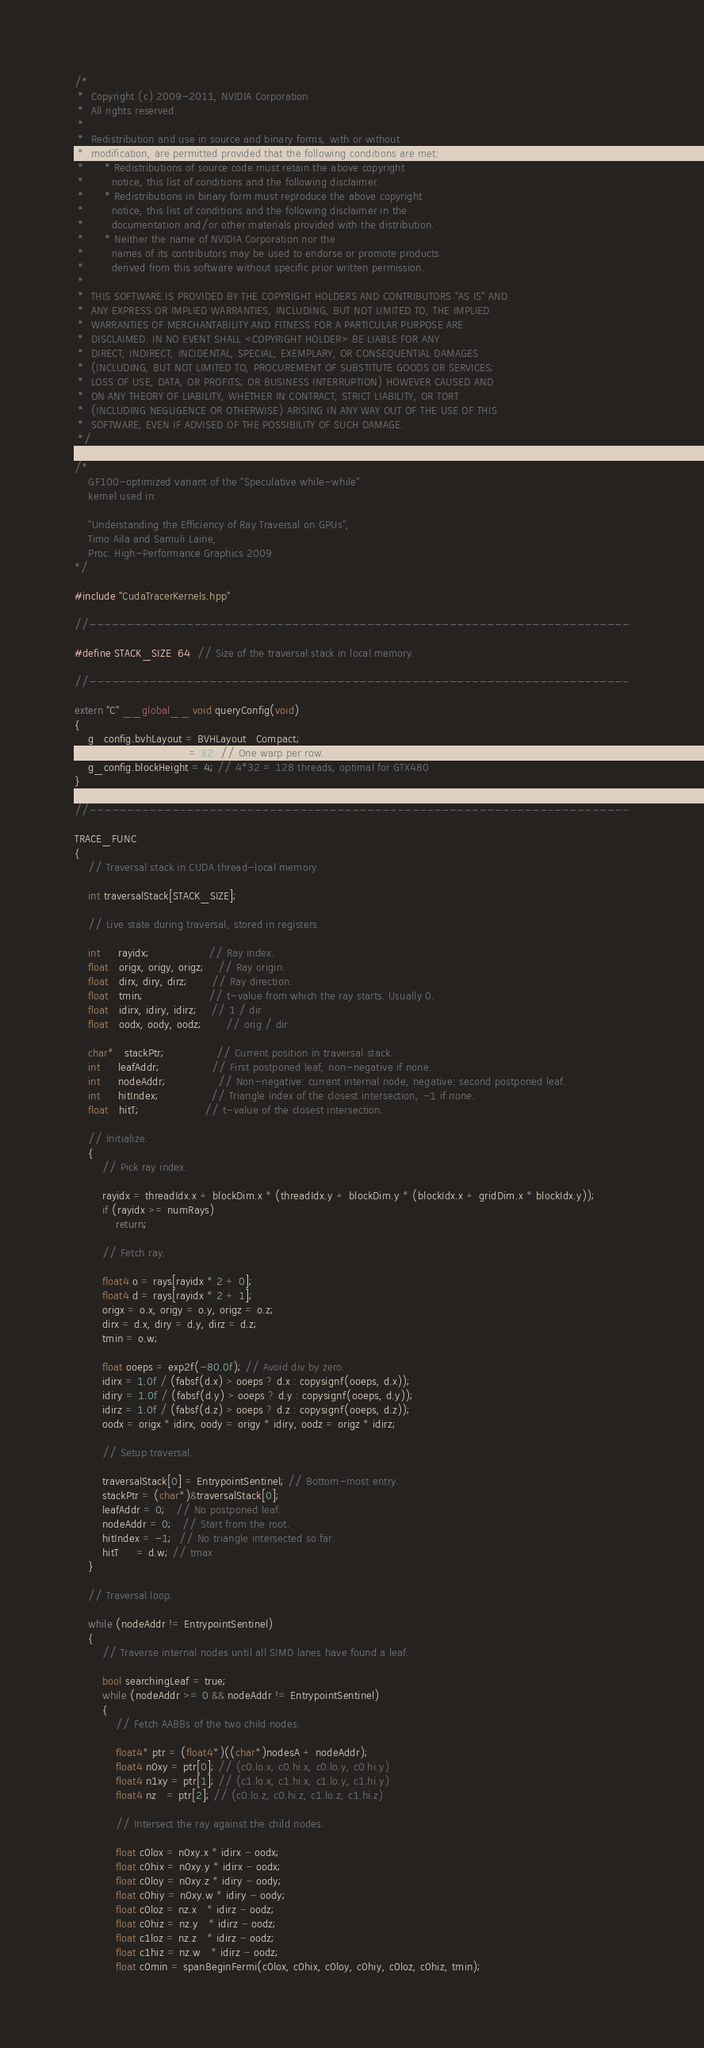Convert code to text. <code><loc_0><loc_0><loc_500><loc_500><_Cuda_>/*
 *  Copyright (c) 2009-2011, NVIDIA Corporation
 *  All rights reserved.
 *
 *  Redistribution and use in source and binary forms, with or without
 *  modification, are permitted provided that the following conditions are met:
 *      * Redistributions of source code must retain the above copyright
 *        notice, this list of conditions and the following disclaimer.
 *      * Redistributions in binary form must reproduce the above copyright
 *        notice, this list of conditions and the following disclaimer in the
 *        documentation and/or other materials provided with the distribution.
 *      * Neither the name of NVIDIA Corporation nor the
 *        names of its contributors may be used to endorse or promote products
 *        derived from this software without specific prior written permission.
 *
 *  THIS SOFTWARE IS PROVIDED BY THE COPYRIGHT HOLDERS AND CONTRIBUTORS "AS IS" AND
 *  ANY EXPRESS OR IMPLIED WARRANTIES, INCLUDING, BUT NOT LIMITED TO, THE IMPLIED
 *  WARRANTIES OF MERCHANTABILITY AND FITNESS FOR A PARTICULAR PURPOSE ARE
 *  DISCLAIMED. IN NO EVENT SHALL <COPYRIGHT HOLDER> BE LIABLE FOR ANY
 *  DIRECT, INDIRECT, INCIDENTAL, SPECIAL, EXEMPLARY, OR CONSEQUENTIAL DAMAGES
 *  (INCLUDING, BUT NOT LIMITED TO, PROCUREMENT OF SUBSTITUTE GOODS OR SERVICES;
 *  LOSS OF USE, DATA, OR PROFITS; OR BUSINESS INTERRUPTION) HOWEVER CAUSED AND
 *  ON ANY THEORY OF LIABILITY, WHETHER IN CONTRACT, STRICT LIABILITY, OR TORT
 *  (INCLUDING NEGLIGENCE OR OTHERWISE) ARISING IN ANY WAY OUT OF THE USE OF THIS
 *  SOFTWARE, EVEN IF ADVISED OF THE POSSIBILITY OF SUCH DAMAGE.
 */

/*
    GF100-optimized variant of the "Speculative while-while"
    kernel used in:

    "Understanding the Efficiency of Ray Traversal on GPUs",
    Timo Aila and Samuli Laine,
    Proc. High-Performance Graphics 2009
*/

#include "CudaTracerKernels.hpp"

//------------------------------------------------------------------------

#define STACK_SIZE  64  // Size of the traversal stack in local memory.

//------------------------------------------------------------------------

extern "C" __global__ void queryConfig(void)
{
    g_config.bvhLayout = BVHLayout_Compact;
    g_config.blockWidth = 32; // One warp per row.
    g_config.blockHeight = 4; // 4*32 = 128 threads, optimal for GTX480
}

//------------------------------------------------------------------------

TRACE_FUNC
{
    // Traversal stack in CUDA thread-local memory.

    int traversalStack[STACK_SIZE];

    // Live state during traversal, stored in registers.

    int     rayidx;                 // Ray index.
    float   origx, origy, origz;    // Ray origin.
    float   dirx, diry, dirz;       // Ray direction.
    float   tmin;                   // t-value from which the ray starts. Usually 0.
    float   idirx, idiry, idirz;    // 1 / dir
    float   oodx, oody, oodz;       // orig / dir

    char*   stackPtr;               // Current position in traversal stack.
    int     leafAddr;               // First postponed leaf, non-negative if none.
    int     nodeAddr;               // Non-negative: current internal node, negative: second postponed leaf.
    int     hitIndex;               // Triangle index of the closest intersection, -1 if none.
    float   hitT;                   // t-value of the closest intersection.

    // Initialize.
    {
        // Pick ray index.

        rayidx = threadIdx.x + blockDim.x * (threadIdx.y + blockDim.y * (blockIdx.x + gridDim.x * blockIdx.y));
        if (rayidx >= numRays)
            return;

        // Fetch ray.

        float4 o = rays[rayidx * 2 + 0];
        float4 d = rays[rayidx * 2 + 1];
        origx = o.x, origy = o.y, origz = o.z;
        dirx = d.x, diry = d.y, dirz = d.z;
        tmin = o.w;

        float ooeps = exp2f(-80.0f); // Avoid div by zero.
        idirx = 1.0f / (fabsf(d.x) > ooeps ? d.x : copysignf(ooeps, d.x));
        idiry = 1.0f / (fabsf(d.y) > ooeps ? d.y : copysignf(ooeps, d.y));
        idirz = 1.0f / (fabsf(d.z) > ooeps ? d.z : copysignf(ooeps, d.z));
        oodx = origx * idirx, oody = origy * idiry, oodz = origz * idirz;

        // Setup traversal.

        traversalStack[0] = EntrypointSentinel; // Bottom-most entry.
        stackPtr = (char*)&traversalStack[0];
        leafAddr = 0;   // No postponed leaf.
        nodeAddr = 0;   // Start from the root.
        hitIndex = -1;  // No triangle intersected so far.
        hitT     = d.w; // tmax
    }

    // Traversal loop.

    while (nodeAddr != EntrypointSentinel)
    {
        // Traverse internal nodes until all SIMD lanes have found a leaf.

        bool searchingLeaf = true;
        while (nodeAddr >= 0 && nodeAddr != EntrypointSentinel)
        {
            // Fetch AABBs of the two child nodes.

            float4* ptr = (float4*)((char*)nodesA + nodeAddr);
            float4 n0xy = ptr[0]; // (c0.lo.x, c0.hi.x, c0.lo.y, c0.hi.y)
            float4 n1xy = ptr[1]; // (c1.lo.x, c1.hi.x, c1.lo.y, c1.hi.y)
            float4 nz   = ptr[2]; // (c0.lo.z, c0.hi.z, c1.lo.z, c1.hi.z)

            // Intersect the ray against the child nodes.

            float c0lox = n0xy.x * idirx - oodx;
            float c0hix = n0xy.y * idirx - oodx;
            float c0loy = n0xy.z * idiry - oody;
            float c0hiy = n0xy.w * idiry - oody;
            float c0loz = nz.x   * idirz - oodz;
            float c0hiz = nz.y   * idirz - oodz;
            float c1loz = nz.z   * idirz - oodz;
            float c1hiz = nz.w   * idirz - oodz;
			float c0min = spanBeginFermi(c0lox, c0hix, c0loy, c0hiy, c0loz, c0hiz, tmin);</code> 